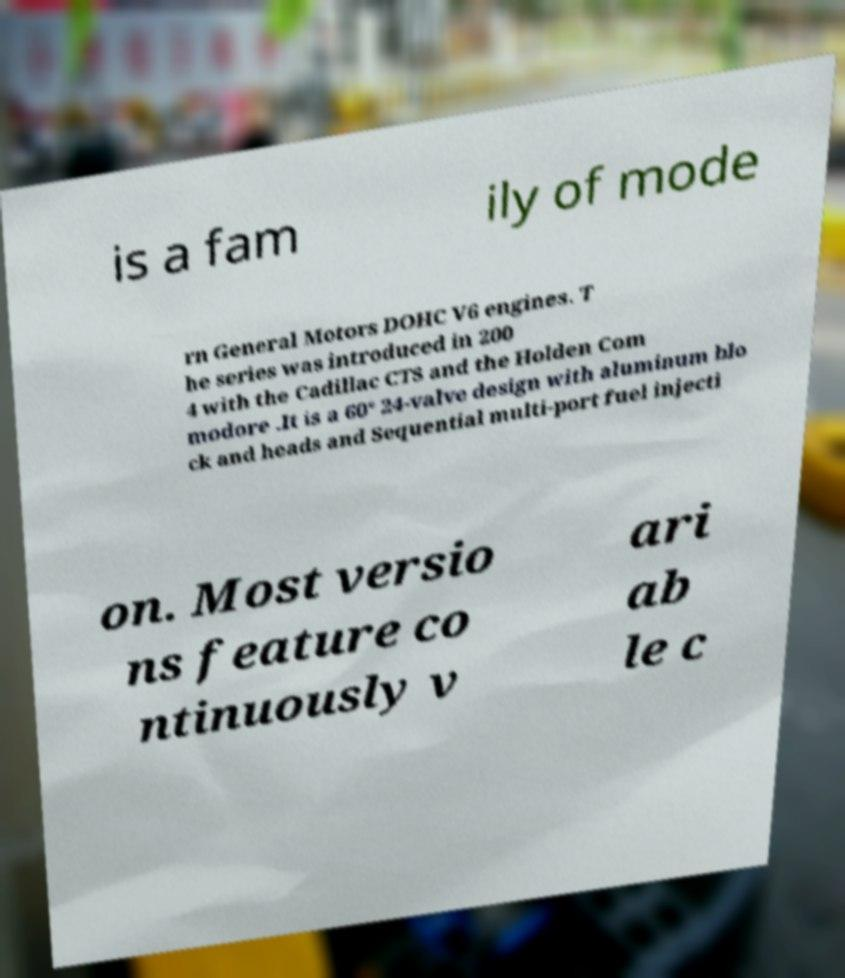I need the written content from this picture converted into text. Can you do that? is a fam ily of mode rn General Motors DOHC V6 engines. T he series was introduced in 200 4 with the Cadillac CTS and the Holden Com modore .It is a 60° 24-valve design with aluminum blo ck and heads and Sequential multi-port fuel injecti on. Most versio ns feature co ntinuously v ari ab le c 